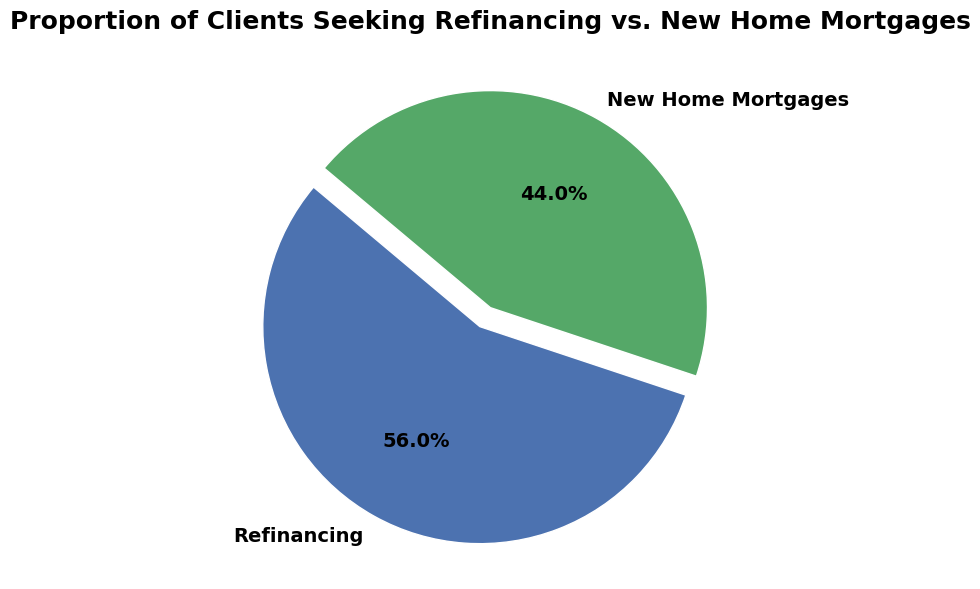What percentage of clients are seeking refinancing? From the pie chart, we see that the wedge labeled 'Refinancing' shows the percentage. The text inside this wedge reads '56.0%', indicating the proportion of clients seeking refinancing.
Answer: 56.0% Which category has more clients? By comparing the sizes of the wedges in the pie chart, we observe that the 'Refinancing' wedge is larger than the 'New Home Mortgages' wedge, signifying more clients.
Answer: Refinancing What is the difference in the number of clients between the two categories? The number of clients for refinancing is 560 and for new home mortgages is 440. The difference between these two numbers is 560 - 440 = 120.
Answer: 120 What proportion of clients are seeking new home mortgages? The wedge labeled 'New Home Mortgages' on the pie chart shows the percentage. The text inside this wedge reads '44.0%', indicating the proportion of clients seeking new home mortgages.
Answer: 44.0% What is the overall percentage of clients interested in either refinancing or new home mortgages? Since the chart only shows two categories, the overall percentage of clients interested in either category will be the sum of the percentages of both categories. 56.0% + 44.0% = 100.0%
Answer: 100.0% Which wedge is exploded in the pie chart? By observing the pie chart, the wedge representing 'Refinancing' is separated slightly from the rest of the chart, indicating it is the exploded wedge.
Answer: Refinancing 